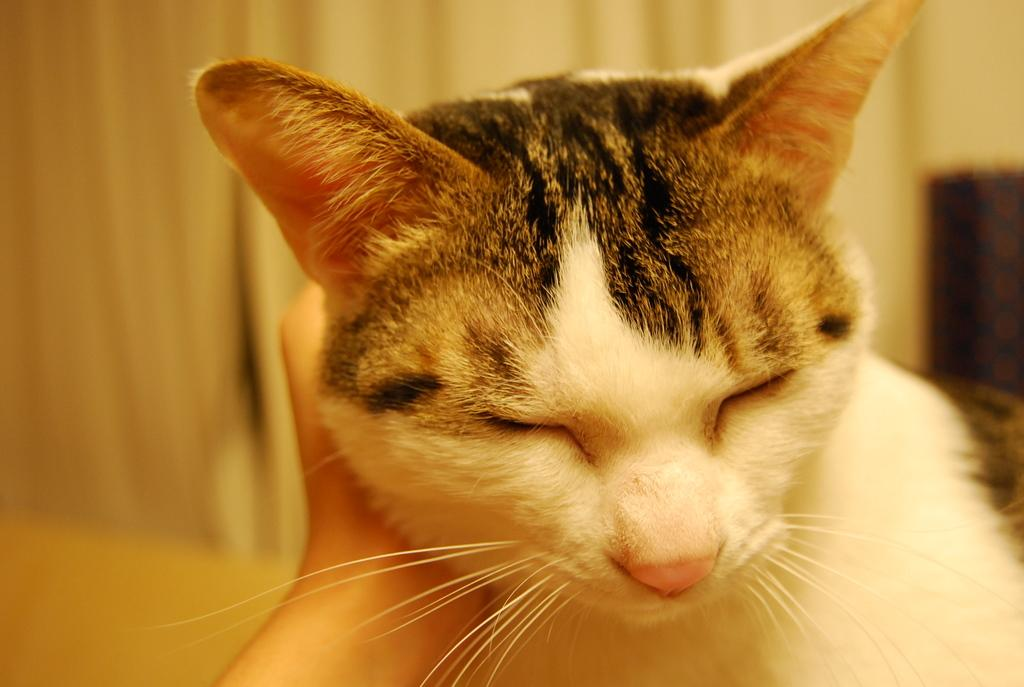What type of animal is in the image? There is a cat in the image. What is the cat doing in the image? The cat is closing its eyes. What type of railway can be seen in the image? There is no railway present in the image; it features a cat closing its eyes. Can you see any sheep in the image? There are no sheep present in the image; it features a cat closing its eyes. 